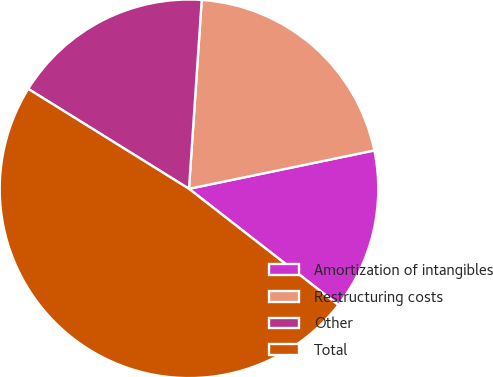<chart> <loc_0><loc_0><loc_500><loc_500><pie_chart><fcel>Amortization of intangibles<fcel>Restructuring costs<fcel>Other<fcel>Total<nl><fcel>13.77%<fcel>20.68%<fcel>17.22%<fcel>48.33%<nl></chart> 